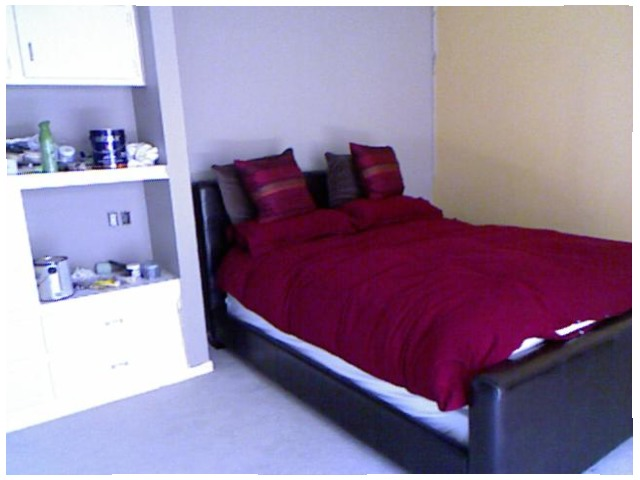<image>
Is the pillow on the bed? Yes. Looking at the image, I can see the pillow is positioned on top of the bed, with the bed providing support. Is there a matress on the floor? No. The matress is not positioned on the floor. They may be near each other, but the matress is not supported by or resting on top of the floor. Is the wall behind the bed? Yes. From this viewpoint, the wall is positioned behind the bed, with the bed partially or fully occluding the wall. 